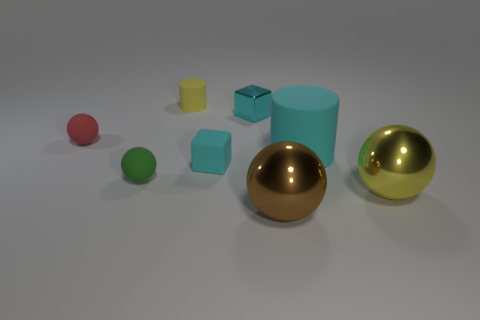How many other objects are the same shape as the green object?
Your response must be concise. 3. There is a ball on the right side of the brown sphere; what number of large cyan objects are behind it?
Ensure brevity in your answer.  1. There is a green ball; how many tiny yellow rubber cylinders are right of it?
Give a very brief answer. 1. How many other objects are the same size as the green rubber ball?
Provide a short and direct response. 4. What size is the other metallic object that is the same shape as the brown metallic object?
Provide a succinct answer. Large. What shape is the yellow object behind the rubber cube?
Make the answer very short. Cylinder. What is the color of the matte object right of the sphere that is in front of the large yellow ball?
Provide a succinct answer. Cyan. How many objects are large spheres that are in front of the big yellow ball or large matte cylinders?
Your answer should be compact. 2. There is a cyan cylinder; is its size the same as the shiny thing behind the yellow metallic thing?
Your answer should be compact. No. How many large objects are either purple metallic spheres or red rubber balls?
Keep it short and to the point. 0. 